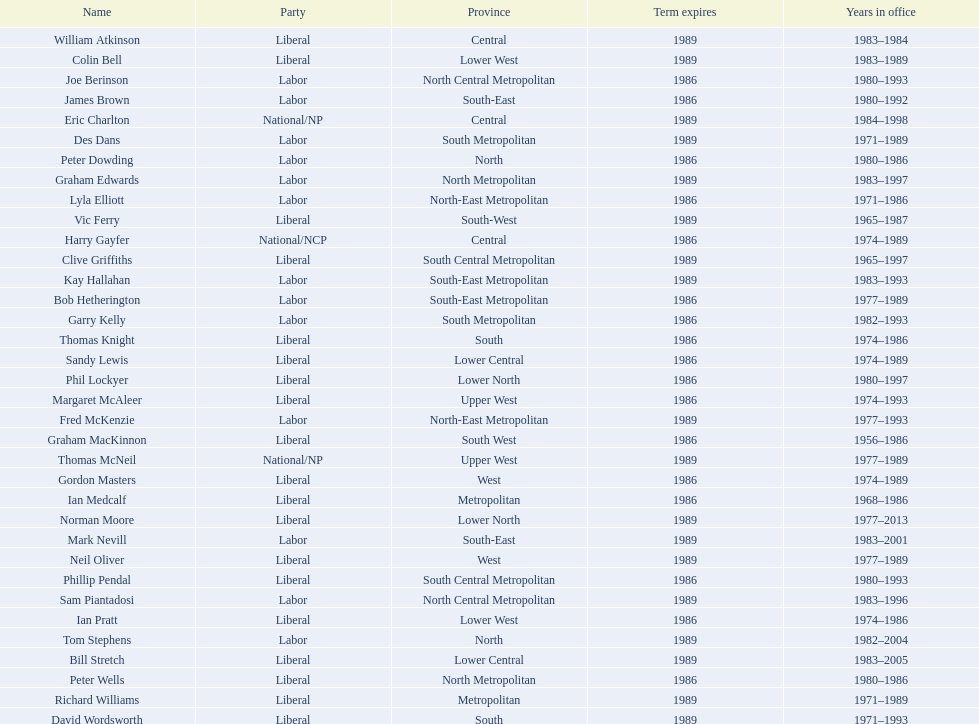Whose time in office was the shortest? William Atkinson. 